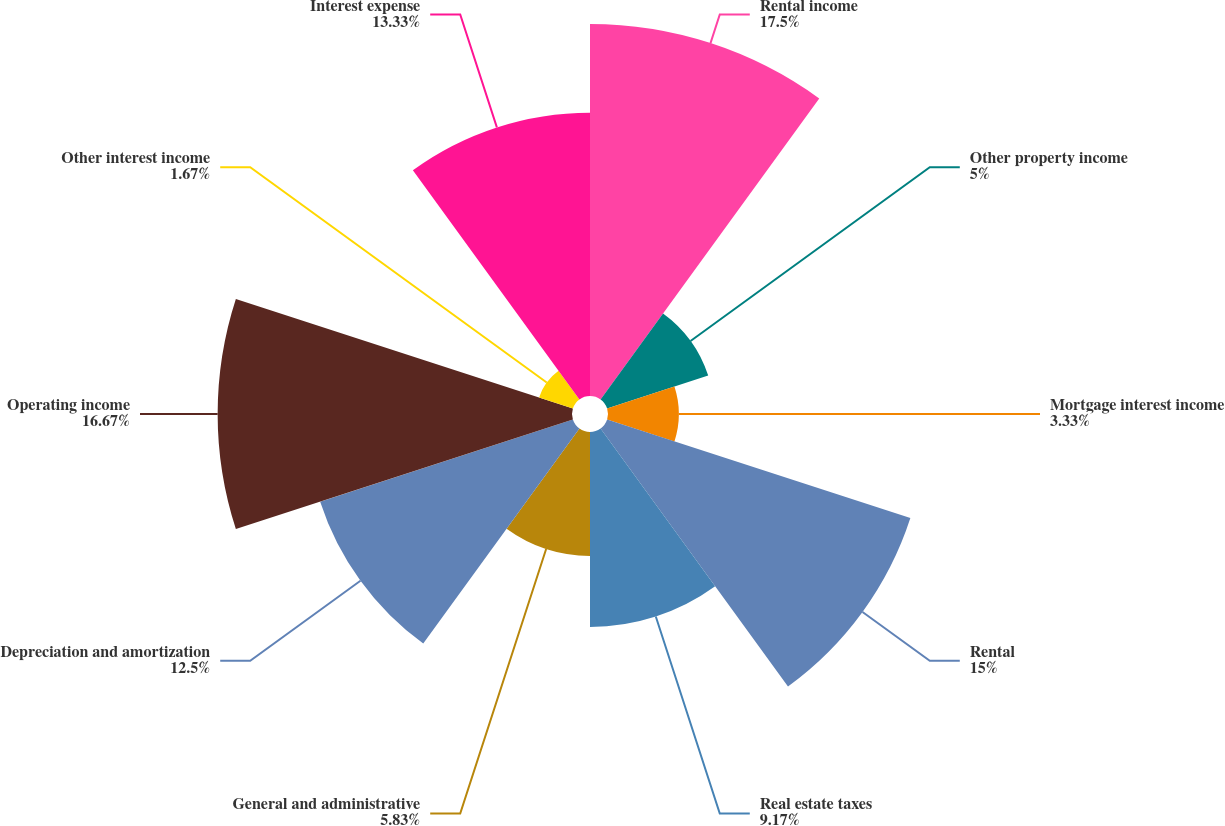Convert chart. <chart><loc_0><loc_0><loc_500><loc_500><pie_chart><fcel>Rental income<fcel>Other property income<fcel>Mortgage interest income<fcel>Rental<fcel>Real estate taxes<fcel>General and administrative<fcel>Depreciation and amortization<fcel>Operating income<fcel>Other interest income<fcel>Interest expense<nl><fcel>17.5%<fcel>5.0%<fcel>3.33%<fcel>15.0%<fcel>9.17%<fcel>5.83%<fcel>12.5%<fcel>16.67%<fcel>1.67%<fcel>13.33%<nl></chart> 